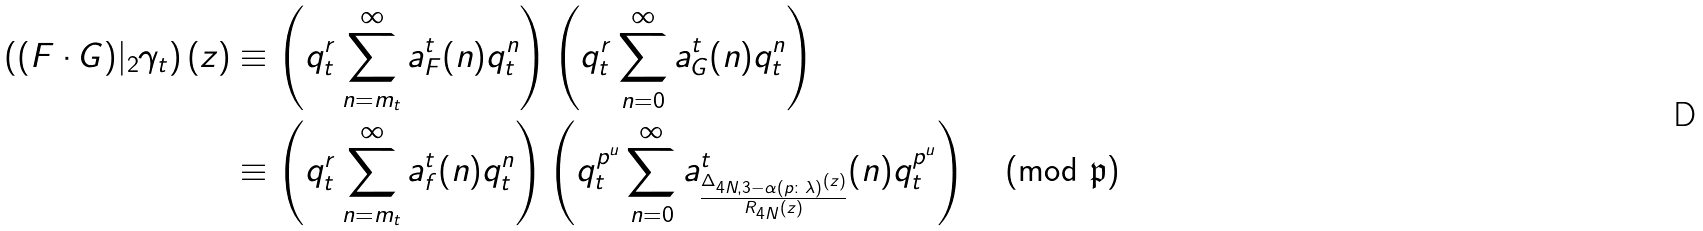Convert formula to latex. <formula><loc_0><loc_0><loc_500><loc_500>\left ( ( F \cdot G ) | _ { 2 } \gamma _ { t } \right ) ( z ) & \equiv \left ( q _ { t } ^ { r } \sum _ { n = m _ { t } } ^ { \infty } a ^ { t } _ { F } ( n ) q _ { t } ^ { n } \right ) \left ( q _ { t } ^ { r } \sum _ { n = 0 } ^ { \infty } a ^ { t } _ { G } ( n ) q _ { t } ^ { n } \right ) \\ & \equiv \left ( q _ { t } ^ { r } \sum _ { n = m _ { t } } ^ { \infty } a ^ { t } _ { f } ( n ) q _ { t } ^ { n } \right ) \left ( q _ { t } ^ { p ^ { u } } \sum _ { n = 0 } ^ { \infty } a _ { \frac { \Delta _ { 4 N , 3 - \alpha ( p \colon \lambda ) } ( z ) } { R _ { 4 N } ( z ) } } ^ { t } ( n ) q _ { t } ^ { p ^ { u } } \right ) \pmod { { \mathfrak { p } } }</formula> 